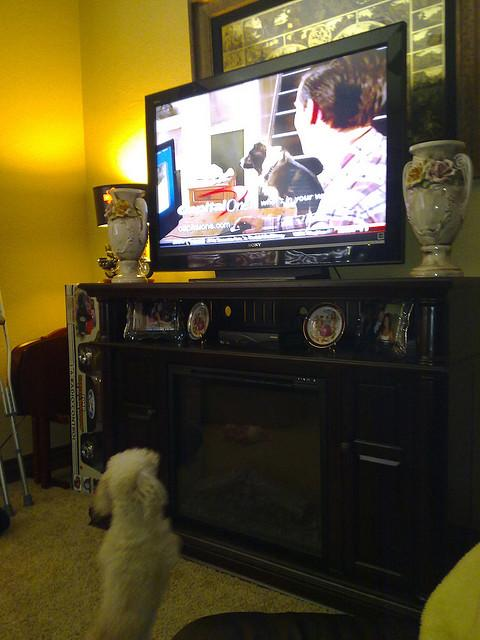What does this dog like on the TV?

Choices:
A) another dog
B) toys
C) cats
D) food another dog 